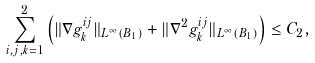Convert formula to latex. <formula><loc_0><loc_0><loc_500><loc_500>\sum _ { i , j , k = 1 } ^ { 2 } \left ( \| \nabla g _ { k } ^ { i j } \| _ { L ^ { \infty } ( B _ { 1 } ) } + \| \nabla ^ { 2 } g _ { k } ^ { i j } \| _ { L ^ { \infty } ( B _ { 1 } ) } \right ) \leq C _ { 2 } ,</formula> 